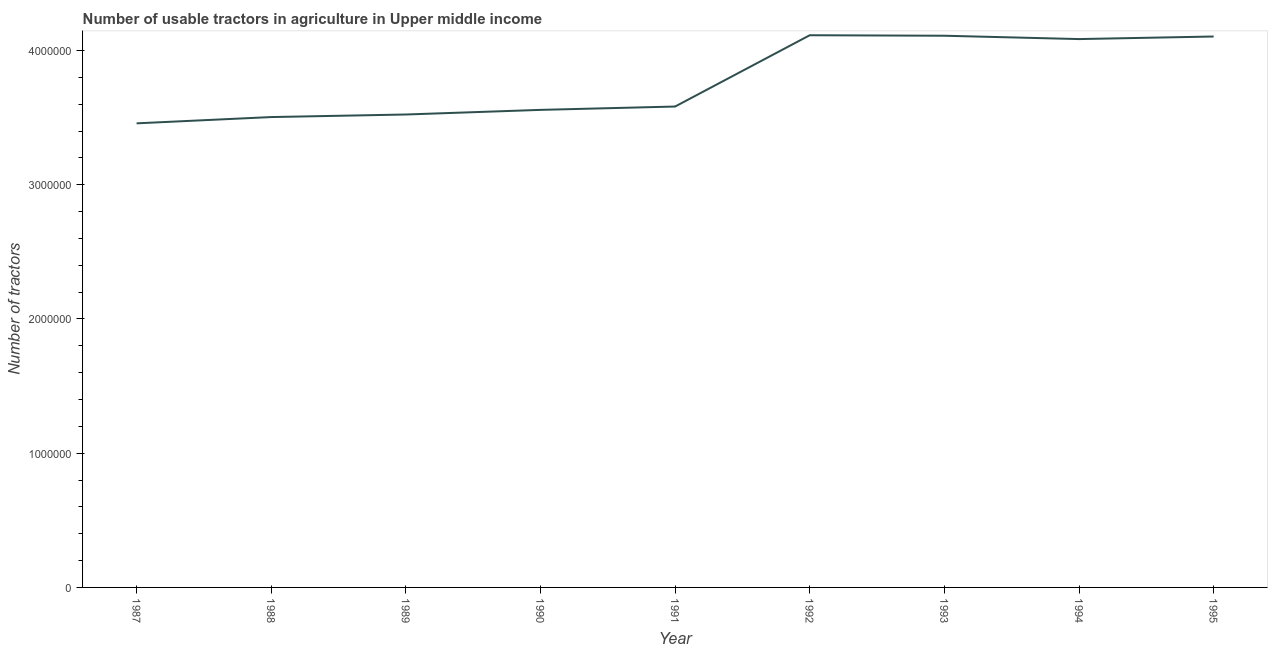What is the number of tractors in 1989?
Your answer should be very brief. 3.52e+06. Across all years, what is the maximum number of tractors?
Give a very brief answer. 4.11e+06. Across all years, what is the minimum number of tractors?
Provide a short and direct response. 3.46e+06. In which year was the number of tractors maximum?
Offer a terse response. 1992. What is the sum of the number of tractors?
Your response must be concise. 3.40e+07. What is the difference between the number of tractors in 1992 and 1994?
Keep it short and to the point. 2.86e+04. What is the average number of tractors per year?
Make the answer very short. 3.78e+06. What is the median number of tractors?
Offer a very short reply. 3.58e+06. In how many years, is the number of tractors greater than 3400000 ?
Give a very brief answer. 9. Do a majority of the years between 1990 and 1992 (inclusive) have number of tractors greater than 1600000 ?
Provide a short and direct response. Yes. What is the ratio of the number of tractors in 1989 to that in 1990?
Your response must be concise. 0.99. Is the number of tractors in 1988 less than that in 1989?
Provide a succinct answer. Yes. What is the difference between the highest and the second highest number of tractors?
Your answer should be very brief. 3729. What is the difference between the highest and the lowest number of tractors?
Give a very brief answer. 6.56e+05. Does the number of tractors monotonically increase over the years?
Your answer should be very brief. No. How many lines are there?
Offer a very short reply. 1. Are the values on the major ticks of Y-axis written in scientific E-notation?
Give a very brief answer. No. Does the graph contain grids?
Provide a short and direct response. No. What is the title of the graph?
Your answer should be compact. Number of usable tractors in agriculture in Upper middle income. What is the label or title of the Y-axis?
Offer a very short reply. Number of tractors. What is the Number of tractors of 1987?
Keep it short and to the point. 3.46e+06. What is the Number of tractors of 1988?
Offer a very short reply. 3.50e+06. What is the Number of tractors in 1989?
Provide a short and direct response. 3.52e+06. What is the Number of tractors in 1990?
Provide a short and direct response. 3.56e+06. What is the Number of tractors in 1991?
Keep it short and to the point. 3.58e+06. What is the Number of tractors of 1992?
Offer a very short reply. 4.11e+06. What is the Number of tractors in 1993?
Give a very brief answer. 4.11e+06. What is the Number of tractors of 1994?
Offer a terse response. 4.09e+06. What is the Number of tractors of 1995?
Make the answer very short. 4.10e+06. What is the difference between the Number of tractors in 1987 and 1988?
Your answer should be very brief. -4.68e+04. What is the difference between the Number of tractors in 1987 and 1989?
Make the answer very short. -6.58e+04. What is the difference between the Number of tractors in 1987 and 1990?
Provide a short and direct response. -1.00e+05. What is the difference between the Number of tractors in 1987 and 1991?
Your answer should be very brief. -1.25e+05. What is the difference between the Number of tractors in 1987 and 1992?
Your response must be concise. -6.56e+05. What is the difference between the Number of tractors in 1987 and 1993?
Provide a short and direct response. -6.53e+05. What is the difference between the Number of tractors in 1987 and 1994?
Offer a very short reply. -6.28e+05. What is the difference between the Number of tractors in 1987 and 1995?
Your answer should be very brief. -6.47e+05. What is the difference between the Number of tractors in 1988 and 1989?
Give a very brief answer. -1.90e+04. What is the difference between the Number of tractors in 1988 and 1990?
Give a very brief answer. -5.35e+04. What is the difference between the Number of tractors in 1988 and 1991?
Provide a short and direct response. -7.84e+04. What is the difference between the Number of tractors in 1988 and 1992?
Provide a short and direct response. -6.10e+05. What is the difference between the Number of tractors in 1988 and 1993?
Offer a terse response. -6.06e+05. What is the difference between the Number of tractors in 1988 and 1994?
Ensure brevity in your answer.  -5.81e+05. What is the difference between the Number of tractors in 1988 and 1995?
Your answer should be very brief. -6.00e+05. What is the difference between the Number of tractors in 1989 and 1990?
Offer a very short reply. -3.45e+04. What is the difference between the Number of tractors in 1989 and 1991?
Provide a succinct answer. -5.94e+04. What is the difference between the Number of tractors in 1989 and 1992?
Your answer should be very brief. -5.91e+05. What is the difference between the Number of tractors in 1989 and 1993?
Provide a succinct answer. -5.87e+05. What is the difference between the Number of tractors in 1989 and 1994?
Ensure brevity in your answer.  -5.62e+05. What is the difference between the Number of tractors in 1989 and 1995?
Offer a very short reply. -5.81e+05. What is the difference between the Number of tractors in 1990 and 1991?
Your answer should be compact. -2.49e+04. What is the difference between the Number of tractors in 1990 and 1992?
Your answer should be compact. -5.56e+05. What is the difference between the Number of tractors in 1990 and 1993?
Provide a short and direct response. -5.52e+05. What is the difference between the Number of tractors in 1990 and 1994?
Your answer should be very brief. -5.27e+05. What is the difference between the Number of tractors in 1990 and 1995?
Make the answer very short. -5.47e+05. What is the difference between the Number of tractors in 1991 and 1992?
Keep it short and to the point. -5.31e+05. What is the difference between the Number of tractors in 1991 and 1993?
Your response must be concise. -5.27e+05. What is the difference between the Number of tractors in 1991 and 1994?
Offer a terse response. -5.03e+05. What is the difference between the Number of tractors in 1991 and 1995?
Your answer should be compact. -5.22e+05. What is the difference between the Number of tractors in 1992 and 1993?
Your answer should be compact. 3729. What is the difference between the Number of tractors in 1992 and 1994?
Your response must be concise. 2.86e+04. What is the difference between the Number of tractors in 1992 and 1995?
Ensure brevity in your answer.  9421. What is the difference between the Number of tractors in 1993 and 1994?
Your answer should be compact. 2.49e+04. What is the difference between the Number of tractors in 1993 and 1995?
Ensure brevity in your answer.  5692. What is the difference between the Number of tractors in 1994 and 1995?
Keep it short and to the point. -1.92e+04. What is the ratio of the Number of tractors in 1987 to that in 1989?
Keep it short and to the point. 0.98. What is the ratio of the Number of tractors in 1987 to that in 1990?
Your answer should be compact. 0.97. What is the ratio of the Number of tractors in 1987 to that in 1992?
Make the answer very short. 0.84. What is the ratio of the Number of tractors in 1987 to that in 1993?
Make the answer very short. 0.84. What is the ratio of the Number of tractors in 1987 to that in 1994?
Make the answer very short. 0.85. What is the ratio of the Number of tractors in 1987 to that in 1995?
Keep it short and to the point. 0.84. What is the ratio of the Number of tractors in 1988 to that in 1992?
Your answer should be very brief. 0.85. What is the ratio of the Number of tractors in 1988 to that in 1993?
Your answer should be compact. 0.85. What is the ratio of the Number of tractors in 1988 to that in 1994?
Provide a short and direct response. 0.86. What is the ratio of the Number of tractors in 1988 to that in 1995?
Your response must be concise. 0.85. What is the ratio of the Number of tractors in 1989 to that in 1992?
Make the answer very short. 0.86. What is the ratio of the Number of tractors in 1989 to that in 1993?
Your answer should be very brief. 0.86. What is the ratio of the Number of tractors in 1989 to that in 1994?
Offer a terse response. 0.86. What is the ratio of the Number of tractors in 1989 to that in 1995?
Provide a short and direct response. 0.86. What is the ratio of the Number of tractors in 1990 to that in 1992?
Keep it short and to the point. 0.86. What is the ratio of the Number of tractors in 1990 to that in 1993?
Ensure brevity in your answer.  0.87. What is the ratio of the Number of tractors in 1990 to that in 1994?
Your answer should be very brief. 0.87. What is the ratio of the Number of tractors in 1990 to that in 1995?
Provide a succinct answer. 0.87. What is the ratio of the Number of tractors in 1991 to that in 1992?
Offer a very short reply. 0.87. What is the ratio of the Number of tractors in 1991 to that in 1993?
Your response must be concise. 0.87. What is the ratio of the Number of tractors in 1991 to that in 1994?
Your answer should be compact. 0.88. What is the ratio of the Number of tractors in 1991 to that in 1995?
Your response must be concise. 0.87. What is the ratio of the Number of tractors in 1992 to that in 1994?
Offer a terse response. 1.01. What is the ratio of the Number of tractors in 1992 to that in 1995?
Your answer should be very brief. 1. What is the ratio of the Number of tractors in 1993 to that in 1994?
Give a very brief answer. 1.01. What is the ratio of the Number of tractors in 1993 to that in 1995?
Give a very brief answer. 1. What is the ratio of the Number of tractors in 1994 to that in 1995?
Offer a terse response. 0.99. 